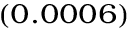<formula> <loc_0><loc_0><loc_500><loc_500>_ { ( 0 . 0 0 0 6 ) }</formula> 